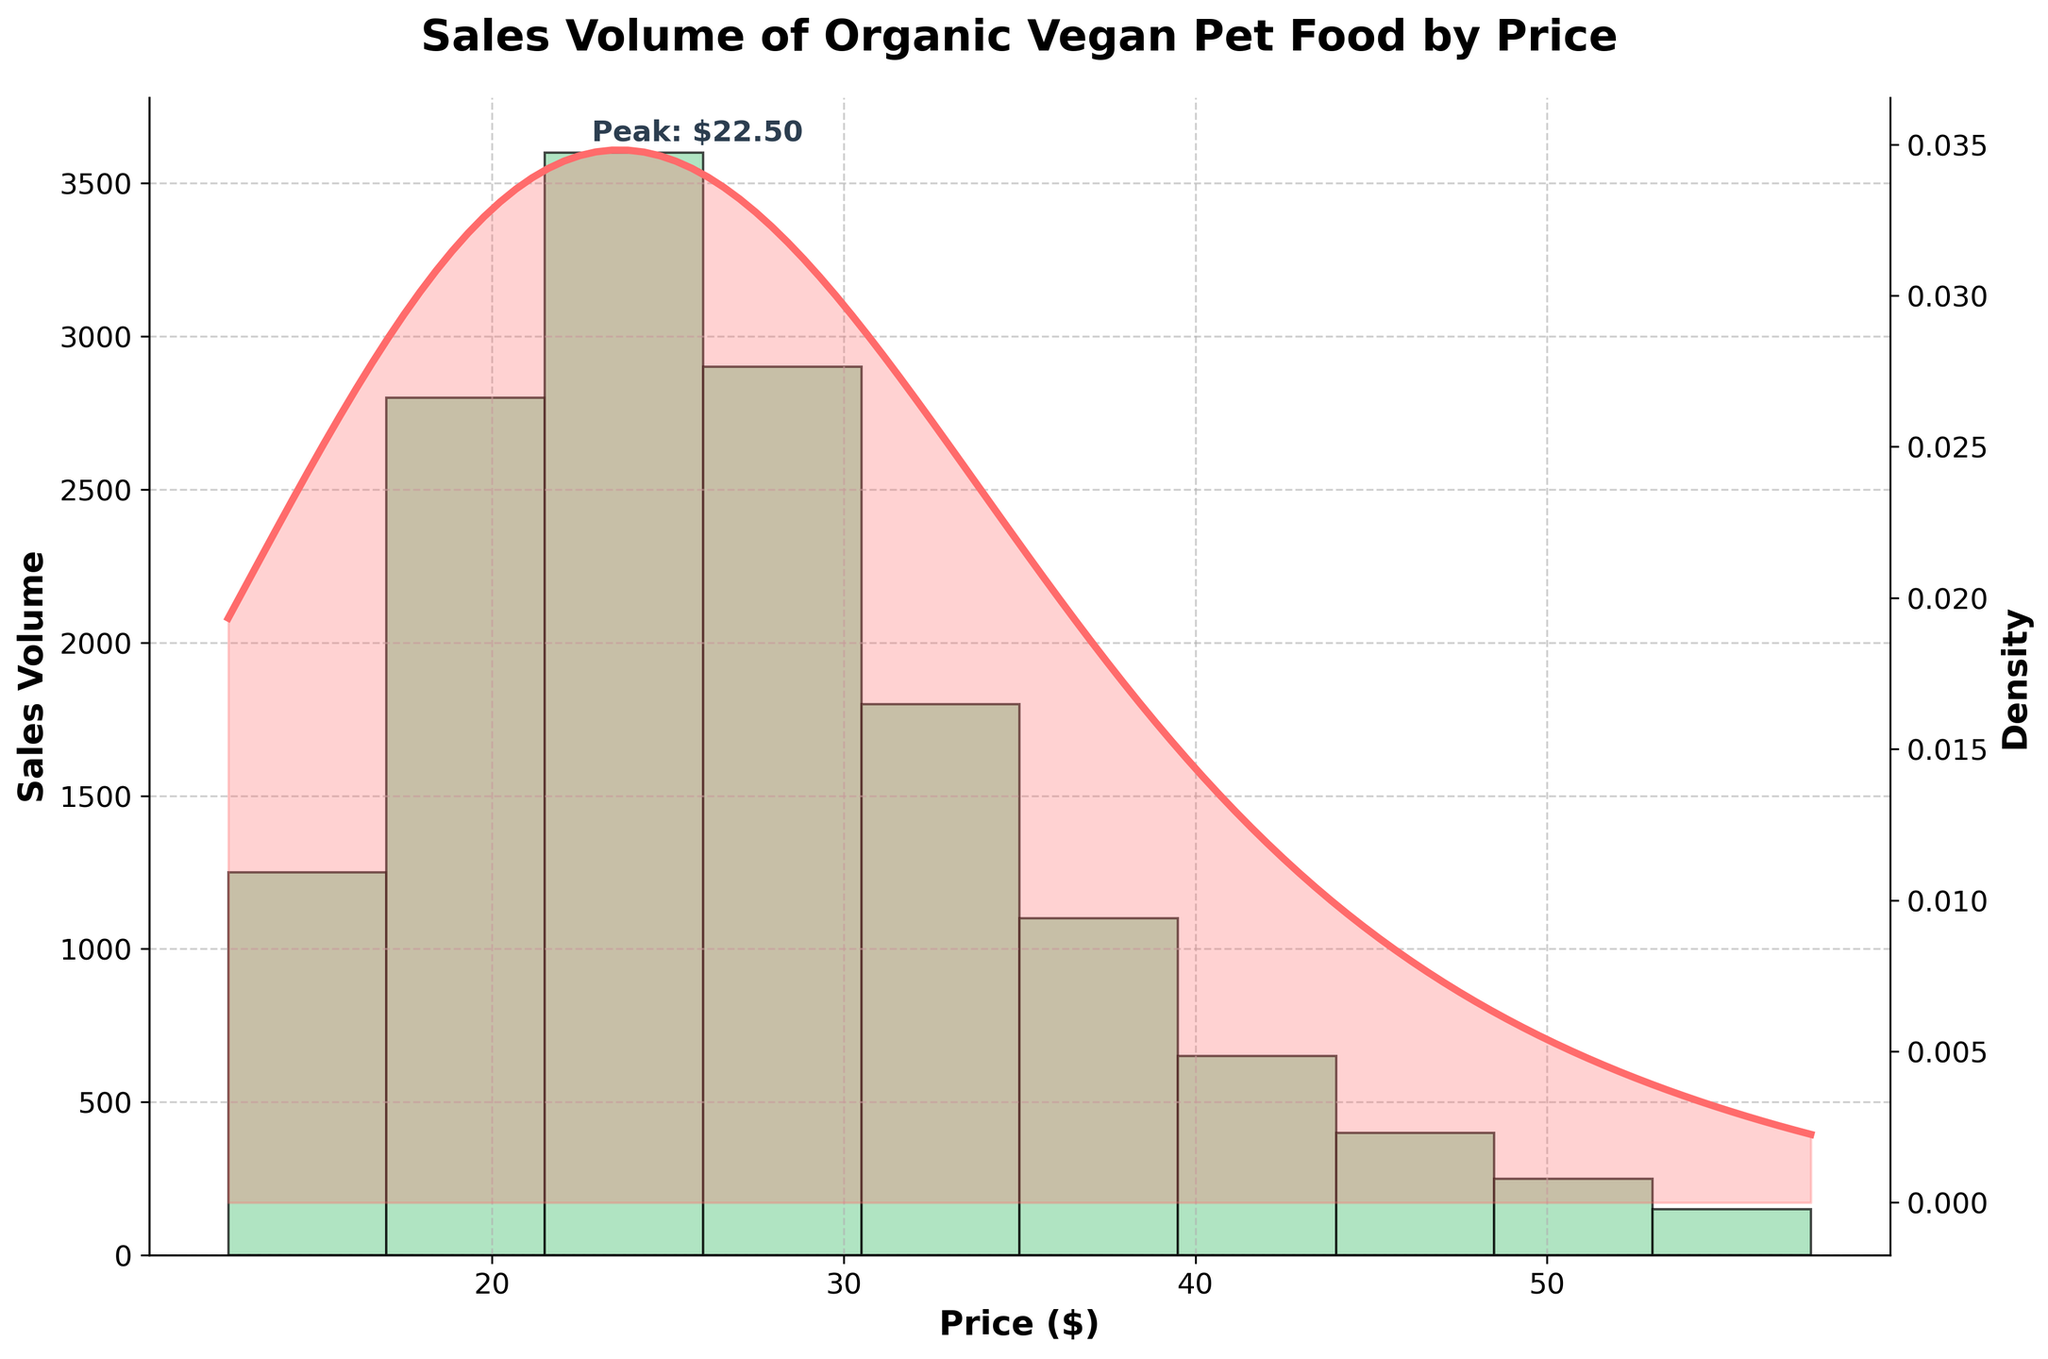What's the title of the figure? The title of the figure is usually found at the top of the plot and is meant to summarize what the figure is about. In this case, it's clearly indicated by a bold text above the plot.
Answer: Sales Volume of Organic Vegan Pet Food by Price What is the range of the x-axis? The x-axis represents the price in dollars and is labeled accordingly. The range can be determined by looking at the lowest and highest price values on this axis.
Answer: $10-$60 Which price point has the highest sales volume? The highest bar in the histogram indicates the price point with the highest sales volume. From the plot, it's clearly seen that this price point is around $20-$25.
Answer: $20-$25 How does sales volume change as price increases from $10 to $60? As price increases, the sales volume initially increases, reaching a peak around the $20-$25 range. After this peak, sales volume gradually decreases as price continues to rise. This overall trend can be visualized by observing the heights of the histogram bars across the price range.
Answer: Increases then decreases Which price range has the least sales volume? The shortest bar in the histogram represents the price range with the least sales volume. By comparing the heights of the bars, you can identify that the price range with the least sales volume is $55-$60.
Answer: $55-$60 What does the density curve represent and how is it depicted in the figure? The density curve, also known as KDE, represents the probability density of the sales volume across different price points. It is depicted as a smooth curve overlaid on the histogram, helping to visualize the distribution of the data.
Answer: Probability density Compare the sales volumes between the $15-$20 and $30-$35 price ranges. By comparing the heights of the histogram bars corresponding to the $15-$20 and $30-$35 price ranges, it is clear that the $15-$20 price range has a significantly higher sales volume.
Answer: $15-$20 has higher sales What can be inferred from the peak in the density curve? The peak in the density curve indicates the price range where the density of sales volume is highest. This corresponds to the price range with the highest sales volume, which is also confirmed by the tallest histogram bar around $20-$25.
Answer: Highest sales volume at $20-$25 How many times higher is the sales volume at $20-$25 compared to $50-$55? By referring to the heights of the histogram bars for these price points, the sales volume at $20-$25 is 3600 and at $50-$55 is 250. Dividing 3600 by 250 gives 14.4, indicating that sales at $20-$25 are 14.4 times higher.
Answer: 14.4 times higher What does the annotation on the figure indicate? The annotation displayed on the figure usually highlights a specific data point, and here it points to the peak sales volume price, which is around $20-$25, as marked on the figure.
Answer: Peak: $22.50 